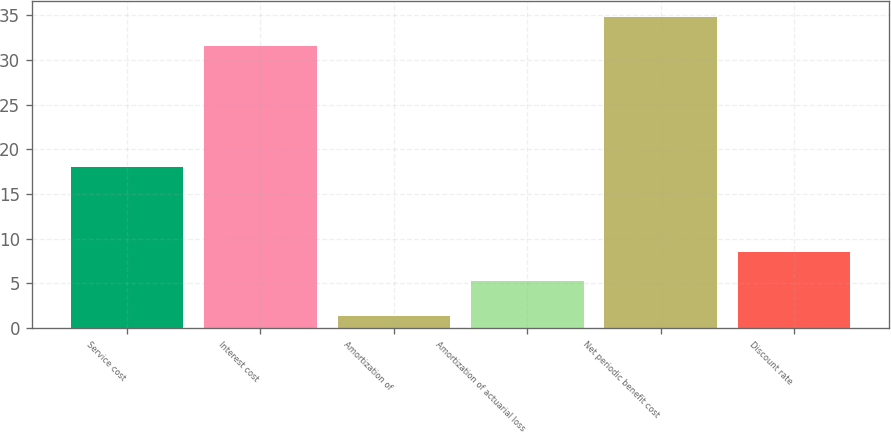<chart> <loc_0><loc_0><loc_500><loc_500><bar_chart><fcel>Service cost<fcel>Interest cost<fcel>Amortization of<fcel>Amortization of actuarial loss<fcel>Net periodic benefit cost<fcel>Discount rate<nl><fcel>18<fcel>31.5<fcel>1.3<fcel>5.2<fcel>34.84<fcel>8.54<nl></chart> 